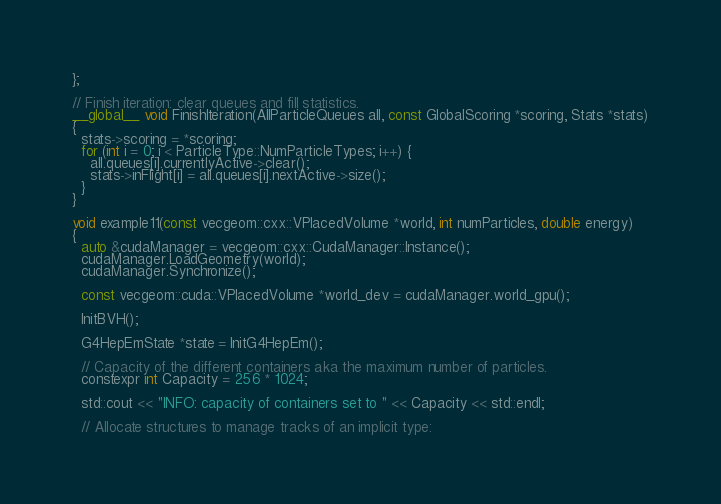Convert code to text. <code><loc_0><loc_0><loc_500><loc_500><_Cuda_>};

// Finish iteration: clear queues and fill statistics.
__global__ void FinishIteration(AllParticleQueues all, const GlobalScoring *scoring, Stats *stats)
{
  stats->scoring = *scoring;
  for (int i = 0; i < ParticleType::NumParticleTypes; i++) {
    all.queues[i].currentlyActive->clear();
    stats->inFlight[i] = all.queues[i].nextActive->size();
  }
}

void example11(const vecgeom::cxx::VPlacedVolume *world, int numParticles, double energy)
{
  auto &cudaManager = vecgeom::cxx::CudaManager::Instance();
  cudaManager.LoadGeometry(world);
  cudaManager.Synchronize();

  const vecgeom::cuda::VPlacedVolume *world_dev = cudaManager.world_gpu();

  InitBVH();

  G4HepEmState *state = InitG4HepEm();

  // Capacity of the different containers aka the maximum number of particles.
  constexpr int Capacity = 256 * 1024;

  std::cout << "INFO: capacity of containers set to " << Capacity << std::endl;

  // Allocate structures to manage tracks of an implicit type:</code> 